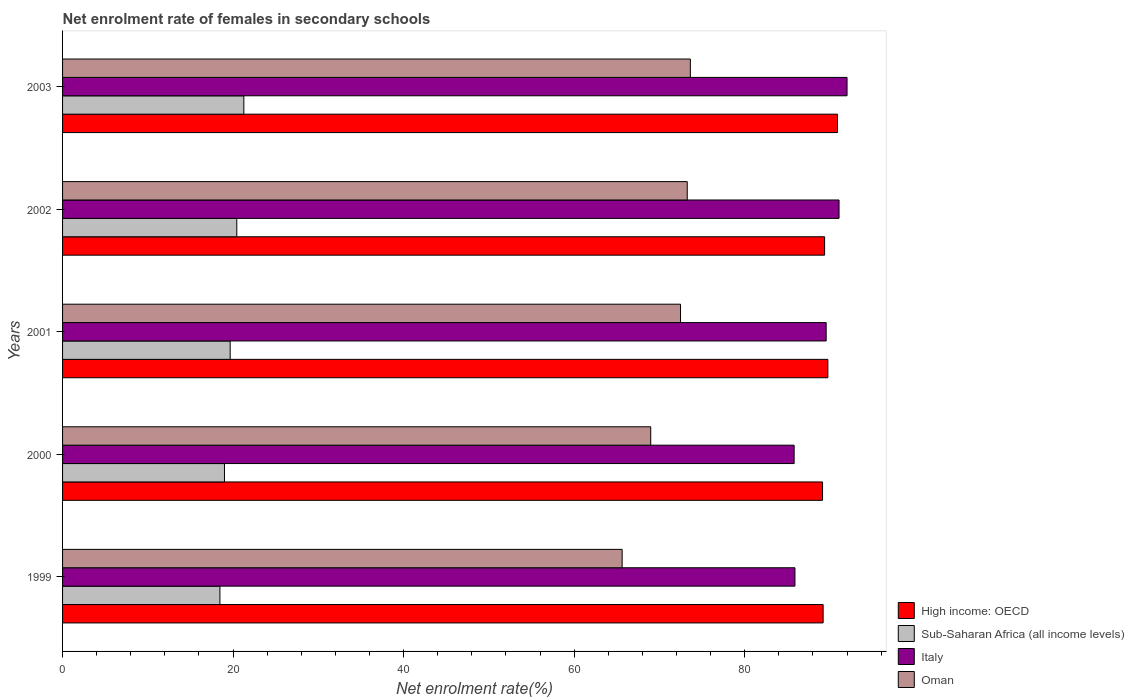How many groups of bars are there?
Your response must be concise. 5. How many bars are there on the 2nd tick from the top?
Provide a succinct answer. 4. In how many cases, is the number of bars for a given year not equal to the number of legend labels?
Provide a succinct answer. 0. What is the net enrolment rate of females in secondary schools in Italy in 2000?
Make the answer very short. 85.8. Across all years, what is the maximum net enrolment rate of females in secondary schools in Italy?
Your answer should be compact. 92.01. Across all years, what is the minimum net enrolment rate of females in secondary schools in Sub-Saharan Africa (all income levels)?
Make the answer very short. 18.45. In which year was the net enrolment rate of females in secondary schools in Oman maximum?
Offer a very short reply. 2003. In which year was the net enrolment rate of females in secondary schools in Sub-Saharan Africa (all income levels) minimum?
Provide a succinct answer. 1999. What is the total net enrolment rate of females in secondary schools in High income: OECD in the graph?
Provide a short and direct response. 448.35. What is the difference between the net enrolment rate of females in secondary schools in Sub-Saharan Africa (all income levels) in 2001 and that in 2002?
Your answer should be compact. -0.78. What is the difference between the net enrolment rate of females in secondary schools in Oman in 2001 and the net enrolment rate of females in secondary schools in Sub-Saharan Africa (all income levels) in 2003?
Your answer should be compact. 51.22. What is the average net enrolment rate of females in secondary schools in Sub-Saharan Africa (all income levels) per year?
Your response must be concise. 19.76. In the year 2003, what is the difference between the net enrolment rate of females in secondary schools in Oman and net enrolment rate of females in secondary schools in High income: OECD?
Keep it short and to the point. -17.26. In how many years, is the net enrolment rate of females in secondary schools in High income: OECD greater than 56 %?
Your answer should be compact. 5. What is the ratio of the net enrolment rate of females in secondary schools in High income: OECD in 2002 to that in 2003?
Keep it short and to the point. 0.98. Is the difference between the net enrolment rate of females in secondary schools in Oman in 2001 and 2003 greater than the difference between the net enrolment rate of females in secondary schools in High income: OECD in 2001 and 2003?
Make the answer very short. No. What is the difference between the highest and the second highest net enrolment rate of females in secondary schools in Sub-Saharan Africa (all income levels)?
Your response must be concise. 0.83. What is the difference between the highest and the lowest net enrolment rate of females in secondary schools in Sub-Saharan Africa (all income levels)?
Offer a terse response. 2.81. Is the sum of the net enrolment rate of females in secondary schools in Oman in 2000 and 2001 greater than the maximum net enrolment rate of females in secondary schools in High income: OECD across all years?
Your response must be concise. Yes. Is it the case that in every year, the sum of the net enrolment rate of females in secondary schools in Italy and net enrolment rate of females in secondary schools in High income: OECD is greater than the sum of net enrolment rate of females in secondary schools in Oman and net enrolment rate of females in secondary schools in Sub-Saharan Africa (all income levels)?
Provide a short and direct response. No. What does the 1st bar from the top in 2002 represents?
Provide a succinct answer. Oman. What does the 4th bar from the bottom in 1999 represents?
Make the answer very short. Oman. How many bars are there?
Keep it short and to the point. 20. How many years are there in the graph?
Make the answer very short. 5. Are the values on the major ticks of X-axis written in scientific E-notation?
Your answer should be very brief. No. Does the graph contain any zero values?
Give a very brief answer. No. Does the graph contain grids?
Ensure brevity in your answer.  No. What is the title of the graph?
Your answer should be very brief. Net enrolment rate of females in secondary schools. Does "Libya" appear as one of the legend labels in the graph?
Make the answer very short. No. What is the label or title of the X-axis?
Make the answer very short. Net enrolment rate(%). What is the label or title of the Y-axis?
Offer a terse response. Years. What is the Net enrolment rate(%) in High income: OECD in 1999?
Provide a succinct answer. 89.2. What is the Net enrolment rate(%) of Sub-Saharan Africa (all income levels) in 1999?
Keep it short and to the point. 18.45. What is the Net enrolment rate(%) in Italy in 1999?
Ensure brevity in your answer.  85.89. What is the Net enrolment rate(%) of Oman in 1999?
Offer a terse response. 65.63. What is the Net enrolment rate(%) in High income: OECD in 2000?
Provide a succinct answer. 89.13. What is the Net enrolment rate(%) of Sub-Saharan Africa (all income levels) in 2000?
Your response must be concise. 18.99. What is the Net enrolment rate(%) in Italy in 2000?
Your answer should be compact. 85.8. What is the Net enrolment rate(%) in Oman in 2000?
Your answer should be compact. 68.98. What is the Net enrolment rate(%) of High income: OECD in 2001?
Make the answer very short. 89.76. What is the Net enrolment rate(%) in Sub-Saharan Africa (all income levels) in 2001?
Your response must be concise. 19.66. What is the Net enrolment rate(%) in Italy in 2001?
Make the answer very short. 89.56. What is the Net enrolment rate(%) in Oman in 2001?
Keep it short and to the point. 72.48. What is the Net enrolment rate(%) in High income: OECD in 2002?
Offer a terse response. 89.37. What is the Net enrolment rate(%) of Sub-Saharan Africa (all income levels) in 2002?
Provide a succinct answer. 20.43. What is the Net enrolment rate(%) of Italy in 2002?
Provide a short and direct response. 91.07. What is the Net enrolment rate(%) in Oman in 2002?
Give a very brief answer. 73.26. What is the Net enrolment rate(%) of High income: OECD in 2003?
Keep it short and to the point. 90.89. What is the Net enrolment rate(%) in Sub-Saharan Africa (all income levels) in 2003?
Keep it short and to the point. 21.26. What is the Net enrolment rate(%) of Italy in 2003?
Keep it short and to the point. 92.01. What is the Net enrolment rate(%) in Oman in 2003?
Provide a short and direct response. 73.63. Across all years, what is the maximum Net enrolment rate(%) of High income: OECD?
Provide a short and direct response. 90.89. Across all years, what is the maximum Net enrolment rate(%) in Sub-Saharan Africa (all income levels)?
Provide a succinct answer. 21.26. Across all years, what is the maximum Net enrolment rate(%) of Italy?
Provide a short and direct response. 92.01. Across all years, what is the maximum Net enrolment rate(%) in Oman?
Provide a succinct answer. 73.63. Across all years, what is the minimum Net enrolment rate(%) of High income: OECD?
Your answer should be very brief. 89.13. Across all years, what is the minimum Net enrolment rate(%) in Sub-Saharan Africa (all income levels)?
Your answer should be compact. 18.45. Across all years, what is the minimum Net enrolment rate(%) in Italy?
Your answer should be very brief. 85.8. Across all years, what is the minimum Net enrolment rate(%) in Oman?
Provide a short and direct response. 65.63. What is the total Net enrolment rate(%) in High income: OECD in the graph?
Your answer should be compact. 448.35. What is the total Net enrolment rate(%) of Sub-Saharan Africa (all income levels) in the graph?
Make the answer very short. 98.79. What is the total Net enrolment rate(%) of Italy in the graph?
Your answer should be very brief. 444.32. What is the total Net enrolment rate(%) of Oman in the graph?
Keep it short and to the point. 353.97. What is the difference between the Net enrolment rate(%) in High income: OECD in 1999 and that in 2000?
Your answer should be compact. 0.07. What is the difference between the Net enrolment rate(%) of Sub-Saharan Africa (all income levels) in 1999 and that in 2000?
Give a very brief answer. -0.53. What is the difference between the Net enrolment rate(%) in Italy in 1999 and that in 2000?
Ensure brevity in your answer.  0.09. What is the difference between the Net enrolment rate(%) of Oman in 1999 and that in 2000?
Give a very brief answer. -3.35. What is the difference between the Net enrolment rate(%) of High income: OECD in 1999 and that in 2001?
Give a very brief answer. -0.56. What is the difference between the Net enrolment rate(%) in Sub-Saharan Africa (all income levels) in 1999 and that in 2001?
Offer a very short reply. -1.2. What is the difference between the Net enrolment rate(%) in Italy in 1999 and that in 2001?
Provide a succinct answer. -3.66. What is the difference between the Net enrolment rate(%) of Oman in 1999 and that in 2001?
Make the answer very short. -6.85. What is the difference between the Net enrolment rate(%) of High income: OECD in 1999 and that in 2002?
Your response must be concise. -0.17. What is the difference between the Net enrolment rate(%) of Sub-Saharan Africa (all income levels) in 1999 and that in 2002?
Your response must be concise. -1.98. What is the difference between the Net enrolment rate(%) in Italy in 1999 and that in 2002?
Your response must be concise. -5.17. What is the difference between the Net enrolment rate(%) of Oman in 1999 and that in 2002?
Your answer should be compact. -7.64. What is the difference between the Net enrolment rate(%) in High income: OECD in 1999 and that in 2003?
Provide a short and direct response. -1.68. What is the difference between the Net enrolment rate(%) of Sub-Saharan Africa (all income levels) in 1999 and that in 2003?
Provide a succinct answer. -2.81. What is the difference between the Net enrolment rate(%) of Italy in 1999 and that in 2003?
Ensure brevity in your answer.  -6.11. What is the difference between the Net enrolment rate(%) in Oman in 1999 and that in 2003?
Keep it short and to the point. -8. What is the difference between the Net enrolment rate(%) of High income: OECD in 2000 and that in 2001?
Ensure brevity in your answer.  -0.63. What is the difference between the Net enrolment rate(%) of Sub-Saharan Africa (all income levels) in 2000 and that in 2001?
Your answer should be very brief. -0.67. What is the difference between the Net enrolment rate(%) of Italy in 2000 and that in 2001?
Ensure brevity in your answer.  -3.76. What is the difference between the Net enrolment rate(%) of Oman in 2000 and that in 2001?
Ensure brevity in your answer.  -3.49. What is the difference between the Net enrolment rate(%) of High income: OECD in 2000 and that in 2002?
Make the answer very short. -0.24. What is the difference between the Net enrolment rate(%) of Sub-Saharan Africa (all income levels) in 2000 and that in 2002?
Make the answer very short. -1.45. What is the difference between the Net enrolment rate(%) in Italy in 2000 and that in 2002?
Your answer should be very brief. -5.27. What is the difference between the Net enrolment rate(%) of Oman in 2000 and that in 2002?
Offer a very short reply. -4.28. What is the difference between the Net enrolment rate(%) of High income: OECD in 2000 and that in 2003?
Make the answer very short. -1.75. What is the difference between the Net enrolment rate(%) of Sub-Saharan Africa (all income levels) in 2000 and that in 2003?
Your response must be concise. -2.27. What is the difference between the Net enrolment rate(%) of Italy in 2000 and that in 2003?
Keep it short and to the point. -6.21. What is the difference between the Net enrolment rate(%) of Oman in 2000 and that in 2003?
Ensure brevity in your answer.  -4.64. What is the difference between the Net enrolment rate(%) in High income: OECD in 2001 and that in 2002?
Ensure brevity in your answer.  0.38. What is the difference between the Net enrolment rate(%) of Sub-Saharan Africa (all income levels) in 2001 and that in 2002?
Ensure brevity in your answer.  -0.78. What is the difference between the Net enrolment rate(%) of Italy in 2001 and that in 2002?
Provide a short and direct response. -1.51. What is the difference between the Net enrolment rate(%) in Oman in 2001 and that in 2002?
Your answer should be very brief. -0.79. What is the difference between the Net enrolment rate(%) in High income: OECD in 2001 and that in 2003?
Provide a short and direct response. -1.13. What is the difference between the Net enrolment rate(%) in Sub-Saharan Africa (all income levels) in 2001 and that in 2003?
Your answer should be compact. -1.6. What is the difference between the Net enrolment rate(%) in Italy in 2001 and that in 2003?
Give a very brief answer. -2.45. What is the difference between the Net enrolment rate(%) of Oman in 2001 and that in 2003?
Provide a succinct answer. -1.15. What is the difference between the Net enrolment rate(%) in High income: OECD in 2002 and that in 2003?
Offer a very short reply. -1.51. What is the difference between the Net enrolment rate(%) in Sub-Saharan Africa (all income levels) in 2002 and that in 2003?
Keep it short and to the point. -0.83. What is the difference between the Net enrolment rate(%) in Italy in 2002 and that in 2003?
Provide a succinct answer. -0.94. What is the difference between the Net enrolment rate(%) of Oman in 2002 and that in 2003?
Your answer should be compact. -0.36. What is the difference between the Net enrolment rate(%) of High income: OECD in 1999 and the Net enrolment rate(%) of Sub-Saharan Africa (all income levels) in 2000?
Your answer should be compact. 70.21. What is the difference between the Net enrolment rate(%) in High income: OECD in 1999 and the Net enrolment rate(%) in Italy in 2000?
Make the answer very short. 3.4. What is the difference between the Net enrolment rate(%) of High income: OECD in 1999 and the Net enrolment rate(%) of Oman in 2000?
Make the answer very short. 20.22. What is the difference between the Net enrolment rate(%) of Sub-Saharan Africa (all income levels) in 1999 and the Net enrolment rate(%) of Italy in 2000?
Make the answer very short. -67.34. What is the difference between the Net enrolment rate(%) in Sub-Saharan Africa (all income levels) in 1999 and the Net enrolment rate(%) in Oman in 2000?
Make the answer very short. -50.53. What is the difference between the Net enrolment rate(%) of Italy in 1999 and the Net enrolment rate(%) of Oman in 2000?
Make the answer very short. 16.91. What is the difference between the Net enrolment rate(%) in High income: OECD in 1999 and the Net enrolment rate(%) in Sub-Saharan Africa (all income levels) in 2001?
Offer a terse response. 69.54. What is the difference between the Net enrolment rate(%) in High income: OECD in 1999 and the Net enrolment rate(%) in Italy in 2001?
Provide a short and direct response. -0.36. What is the difference between the Net enrolment rate(%) of High income: OECD in 1999 and the Net enrolment rate(%) of Oman in 2001?
Your answer should be very brief. 16.72. What is the difference between the Net enrolment rate(%) of Sub-Saharan Africa (all income levels) in 1999 and the Net enrolment rate(%) of Italy in 2001?
Ensure brevity in your answer.  -71.1. What is the difference between the Net enrolment rate(%) in Sub-Saharan Africa (all income levels) in 1999 and the Net enrolment rate(%) in Oman in 2001?
Your response must be concise. -54.02. What is the difference between the Net enrolment rate(%) of Italy in 1999 and the Net enrolment rate(%) of Oman in 2001?
Offer a very short reply. 13.42. What is the difference between the Net enrolment rate(%) in High income: OECD in 1999 and the Net enrolment rate(%) in Sub-Saharan Africa (all income levels) in 2002?
Keep it short and to the point. 68.77. What is the difference between the Net enrolment rate(%) in High income: OECD in 1999 and the Net enrolment rate(%) in Italy in 2002?
Provide a short and direct response. -1.87. What is the difference between the Net enrolment rate(%) in High income: OECD in 1999 and the Net enrolment rate(%) in Oman in 2002?
Your answer should be very brief. 15.94. What is the difference between the Net enrolment rate(%) in Sub-Saharan Africa (all income levels) in 1999 and the Net enrolment rate(%) in Italy in 2002?
Provide a succinct answer. -72.61. What is the difference between the Net enrolment rate(%) in Sub-Saharan Africa (all income levels) in 1999 and the Net enrolment rate(%) in Oman in 2002?
Your response must be concise. -54.81. What is the difference between the Net enrolment rate(%) in Italy in 1999 and the Net enrolment rate(%) in Oman in 2002?
Make the answer very short. 12.63. What is the difference between the Net enrolment rate(%) of High income: OECD in 1999 and the Net enrolment rate(%) of Sub-Saharan Africa (all income levels) in 2003?
Provide a short and direct response. 67.94. What is the difference between the Net enrolment rate(%) in High income: OECD in 1999 and the Net enrolment rate(%) in Italy in 2003?
Offer a terse response. -2.8. What is the difference between the Net enrolment rate(%) of High income: OECD in 1999 and the Net enrolment rate(%) of Oman in 2003?
Ensure brevity in your answer.  15.57. What is the difference between the Net enrolment rate(%) of Sub-Saharan Africa (all income levels) in 1999 and the Net enrolment rate(%) of Italy in 2003?
Ensure brevity in your answer.  -73.55. What is the difference between the Net enrolment rate(%) in Sub-Saharan Africa (all income levels) in 1999 and the Net enrolment rate(%) in Oman in 2003?
Your response must be concise. -55.17. What is the difference between the Net enrolment rate(%) in Italy in 1999 and the Net enrolment rate(%) in Oman in 2003?
Make the answer very short. 12.27. What is the difference between the Net enrolment rate(%) of High income: OECD in 2000 and the Net enrolment rate(%) of Sub-Saharan Africa (all income levels) in 2001?
Keep it short and to the point. 69.47. What is the difference between the Net enrolment rate(%) of High income: OECD in 2000 and the Net enrolment rate(%) of Italy in 2001?
Keep it short and to the point. -0.43. What is the difference between the Net enrolment rate(%) in High income: OECD in 2000 and the Net enrolment rate(%) in Oman in 2001?
Your response must be concise. 16.65. What is the difference between the Net enrolment rate(%) in Sub-Saharan Africa (all income levels) in 2000 and the Net enrolment rate(%) in Italy in 2001?
Offer a terse response. -70.57. What is the difference between the Net enrolment rate(%) of Sub-Saharan Africa (all income levels) in 2000 and the Net enrolment rate(%) of Oman in 2001?
Your response must be concise. -53.49. What is the difference between the Net enrolment rate(%) in Italy in 2000 and the Net enrolment rate(%) in Oman in 2001?
Make the answer very short. 13.32. What is the difference between the Net enrolment rate(%) in High income: OECD in 2000 and the Net enrolment rate(%) in Sub-Saharan Africa (all income levels) in 2002?
Your response must be concise. 68.7. What is the difference between the Net enrolment rate(%) of High income: OECD in 2000 and the Net enrolment rate(%) of Italy in 2002?
Your response must be concise. -1.94. What is the difference between the Net enrolment rate(%) in High income: OECD in 2000 and the Net enrolment rate(%) in Oman in 2002?
Your answer should be very brief. 15.87. What is the difference between the Net enrolment rate(%) of Sub-Saharan Africa (all income levels) in 2000 and the Net enrolment rate(%) of Italy in 2002?
Provide a short and direct response. -72.08. What is the difference between the Net enrolment rate(%) of Sub-Saharan Africa (all income levels) in 2000 and the Net enrolment rate(%) of Oman in 2002?
Give a very brief answer. -54.27. What is the difference between the Net enrolment rate(%) in Italy in 2000 and the Net enrolment rate(%) in Oman in 2002?
Offer a very short reply. 12.54. What is the difference between the Net enrolment rate(%) of High income: OECD in 2000 and the Net enrolment rate(%) of Sub-Saharan Africa (all income levels) in 2003?
Provide a succinct answer. 67.87. What is the difference between the Net enrolment rate(%) in High income: OECD in 2000 and the Net enrolment rate(%) in Italy in 2003?
Offer a terse response. -2.87. What is the difference between the Net enrolment rate(%) of High income: OECD in 2000 and the Net enrolment rate(%) of Oman in 2003?
Provide a succinct answer. 15.5. What is the difference between the Net enrolment rate(%) of Sub-Saharan Africa (all income levels) in 2000 and the Net enrolment rate(%) of Italy in 2003?
Provide a succinct answer. -73.02. What is the difference between the Net enrolment rate(%) of Sub-Saharan Africa (all income levels) in 2000 and the Net enrolment rate(%) of Oman in 2003?
Your response must be concise. -54.64. What is the difference between the Net enrolment rate(%) in Italy in 2000 and the Net enrolment rate(%) in Oman in 2003?
Your response must be concise. 12.17. What is the difference between the Net enrolment rate(%) in High income: OECD in 2001 and the Net enrolment rate(%) in Sub-Saharan Africa (all income levels) in 2002?
Offer a terse response. 69.32. What is the difference between the Net enrolment rate(%) of High income: OECD in 2001 and the Net enrolment rate(%) of Italy in 2002?
Ensure brevity in your answer.  -1.31. What is the difference between the Net enrolment rate(%) of High income: OECD in 2001 and the Net enrolment rate(%) of Oman in 2002?
Offer a terse response. 16.49. What is the difference between the Net enrolment rate(%) in Sub-Saharan Africa (all income levels) in 2001 and the Net enrolment rate(%) in Italy in 2002?
Your answer should be very brief. -71.41. What is the difference between the Net enrolment rate(%) in Sub-Saharan Africa (all income levels) in 2001 and the Net enrolment rate(%) in Oman in 2002?
Offer a very short reply. -53.6. What is the difference between the Net enrolment rate(%) in Italy in 2001 and the Net enrolment rate(%) in Oman in 2002?
Keep it short and to the point. 16.29. What is the difference between the Net enrolment rate(%) of High income: OECD in 2001 and the Net enrolment rate(%) of Sub-Saharan Africa (all income levels) in 2003?
Your answer should be compact. 68.5. What is the difference between the Net enrolment rate(%) in High income: OECD in 2001 and the Net enrolment rate(%) in Italy in 2003?
Keep it short and to the point. -2.25. What is the difference between the Net enrolment rate(%) of High income: OECD in 2001 and the Net enrolment rate(%) of Oman in 2003?
Your answer should be very brief. 16.13. What is the difference between the Net enrolment rate(%) in Sub-Saharan Africa (all income levels) in 2001 and the Net enrolment rate(%) in Italy in 2003?
Make the answer very short. -72.35. What is the difference between the Net enrolment rate(%) in Sub-Saharan Africa (all income levels) in 2001 and the Net enrolment rate(%) in Oman in 2003?
Your answer should be compact. -53.97. What is the difference between the Net enrolment rate(%) in Italy in 2001 and the Net enrolment rate(%) in Oman in 2003?
Make the answer very short. 15.93. What is the difference between the Net enrolment rate(%) in High income: OECD in 2002 and the Net enrolment rate(%) in Sub-Saharan Africa (all income levels) in 2003?
Keep it short and to the point. 68.11. What is the difference between the Net enrolment rate(%) of High income: OECD in 2002 and the Net enrolment rate(%) of Italy in 2003?
Offer a very short reply. -2.63. What is the difference between the Net enrolment rate(%) in High income: OECD in 2002 and the Net enrolment rate(%) in Oman in 2003?
Ensure brevity in your answer.  15.75. What is the difference between the Net enrolment rate(%) in Sub-Saharan Africa (all income levels) in 2002 and the Net enrolment rate(%) in Italy in 2003?
Your answer should be compact. -71.57. What is the difference between the Net enrolment rate(%) in Sub-Saharan Africa (all income levels) in 2002 and the Net enrolment rate(%) in Oman in 2003?
Offer a terse response. -53.19. What is the difference between the Net enrolment rate(%) in Italy in 2002 and the Net enrolment rate(%) in Oman in 2003?
Provide a short and direct response. 17.44. What is the average Net enrolment rate(%) in High income: OECD per year?
Keep it short and to the point. 89.67. What is the average Net enrolment rate(%) of Sub-Saharan Africa (all income levels) per year?
Offer a terse response. 19.76. What is the average Net enrolment rate(%) in Italy per year?
Offer a very short reply. 88.86. What is the average Net enrolment rate(%) of Oman per year?
Provide a short and direct response. 70.79. In the year 1999, what is the difference between the Net enrolment rate(%) of High income: OECD and Net enrolment rate(%) of Sub-Saharan Africa (all income levels)?
Keep it short and to the point. 70.75. In the year 1999, what is the difference between the Net enrolment rate(%) in High income: OECD and Net enrolment rate(%) in Italy?
Offer a terse response. 3.31. In the year 1999, what is the difference between the Net enrolment rate(%) of High income: OECD and Net enrolment rate(%) of Oman?
Provide a succinct answer. 23.57. In the year 1999, what is the difference between the Net enrolment rate(%) of Sub-Saharan Africa (all income levels) and Net enrolment rate(%) of Italy?
Offer a very short reply. -67.44. In the year 1999, what is the difference between the Net enrolment rate(%) of Sub-Saharan Africa (all income levels) and Net enrolment rate(%) of Oman?
Offer a terse response. -47.17. In the year 1999, what is the difference between the Net enrolment rate(%) in Italy and Net enrolment rate(%) in Oman?
Your response must be concise. 20.27. In the year 2000, what is the difference between the Net enrolment rate(%) of High income: OECD and Net enrolment rate(%) of Sub-Saharan Africa (all income levels)?
Make the answer very short. 70.14. In the year 2000, what is the difference between the Net enrolment rate(%) of High income: OECD and Net enrolment rate(%) of Italy?
Give a very brief answer. 3.33. In the year 2000, what is the difference between the Net enrolment rate(%) of High income: OECD and Net enrolment rate(%) of Oman?
Keep it short and to the point. 20.15. In the year 2000, what is the difference between the Net enrolment rate(%) of Sub-Saharan Africa (all income levels) and Net enrolment rate(%) of Italy?
Your answer should be compact. -66.81. In the year 2000, what is the difference between the Net enrolment rate(%) in Sub-Saharan Africa (all income levels) and Net enrolment rate(%) in Oman?
Provide a short and direct response. -49.99. In the year 2000, what is the difference between the Net enrolment rate(%) in Italy and Net enrolment rate(%) in Oman?
Your answer should be very brief. 16.82. In the year 2001, what is the difference between the Net enrolment rate(%) of High income: OECD and Net enrolment rate(%) of Sub-Saharan Africa (all income levels)?
Provide a short and direct response. 70.1. In the year 2001, what is the difference between the Net enrolment rate(%) in High income: OECD and Net enrolment rate(%) in Italy?
Offer a very short reply. 0.2. In the year 2001, what is the difference between the Net enrolment rate(%) in High income: OECD and Net enrolment rate(%) in Oman?
Offer a very short reply. 17.28. In the year 2001, what is the difference between the Net enrolment rate(%) of Sub-Saharan Africa (all income levels) and Net enrolment rate(%) of Italy?
Ensure brevity in your answer.  -69.9. In the year 2001, what is the difference between the Net enrolment rate(%) in Sub-Saharan Africa (all income levels) and Net enrolment rate(%) in Oman?
Your answer should be very brief. -52.82. In the year 2001, what is the difference between the Net enrolment rate(%) of Italy and Net enrolment rate(%) of Oman?
Your answer should be very brief. 17.08. In the year 2002, what is the difference between the Net enrolment rate(%) of High income: OECD and Net enrolment rate(%) of Sub-Saharan Africa (all income levels)?
Make the answer very short. 68.94. In the year 2002, what is the difference between the Net enrolment rate(%) in High income: OECD and Net enrolment rate(%) in Italy?
Keep it short and to the point. -1.7. In the year 2002, what is the difference between the Net enrolment rate(%) in High income: OECD and Net enrolment rate(%) in Oman?
Offer a very short reply. 16.11. In the year 2002, what is the difference between the Net enrolment rate(%) of Sub-Saharan Africa (all income levels) and Net enrolment rate(%) of Italy?
Keep it short and to the point. -70.63. In the year 2002, what is the difference between the Net enrolment rate(%) of Sub-Saharan Africa (all income levels) and Net enrolment rate(%) of Oman?
Give a very brief answer. -52.83. In the year 2002, what is the difference between the Net enrolment rate(%) in Italy and Net enrolment rate(%) in Oman?
Your answer should be compact. 17.8. In the year 2003, what is the difference between the Net enrolment rate(%) in High income: OECD and Net enrolment rate(%) in Sub-Saharan Africa (all income levels)?
Your response must be concise. 69.63. In the year 2003, what is the difference between the Net enrolment rate(%) in High income: OECD and Net enrolment rate(%) in Italy?
Offer a terse response. -1.12. In the year 2003, what is the difference between the Net enrolment rate(%) of High income: OECD and Net enrolment rate(%) of Oman?
Your answer should be compact. 17.26. In the year 2003, what is the difference between the Net enrolment rate(%) in Sub-Saharan Africa (all income levels) and Net enrolment rate(%) in Italy?
Ensure brevity in your answer.  -70.75. In the year 2003, what is the difference between the Net enrolment rate(%) in Sub-Saharan Africa (all income levels) and Net enrolment rate(%) in Oman?
Your answer should be very brief. -52.37. In the year 2003, what is the difference between the Net enrolment rate(%) in Italy and Net enrolment rate(%) in Oman?
Give a very brief answer. 18.38. What is the ratio of the Net enrolment rate(%) in High income: OECD in 1999 to that in 2000?
Ensure brevity in your answer.  1. What is the ratio of the Net enrolment rate(%) in Sub-Saharan Africa (all income levels) in 1999 to that in 2000?
Your answer should be compact. 0.97. What is the ratio of the Net enrolment rate(%) of Oman in 1999 to that in 2000?
Offer a terse response. 0.95. What is the ratio of the Net enrolment rate(%) in Sub-Saharan Africa (all income levels) in 1999 to that in 2001?
Offer a very short reply. 0.94. What is the ratio of the Net enrolment rate(%) in Italy in 1999 to that in 2001?
Your answer should be very brief. 0.96. What is the ratio of the Net enrolment rate(%) of Oman in 1999 to that in 2001?
Provide a succinct answer. 0.91. What is the ratio of the Net enrolment rate(%) in Sub-Saharan Africa (all income levels) in 1999 to that in 2002?
Ensure brevity in your answer.  0.9. What is the ratio of the Net enrolment rate(%) in Italy in 1999 to that in 2002?
Make the answer very short. 0.94. What is the ratio of the Net enrolment rate(%) of Oman in 1999 to that in 2002?
Your answer should be very brief. 0.9. What is the ratio of the Net enrolment rate(%) in High income: OECD in 1999 to that in 2003?
Provide a short and direct response. 0.98. What is the ratio of the Net enrolment rate(%) in Sub-Saharan Africa (all income levels) in 1999 to that in 2003?
Provide a succinct answer. 0.87. What is the ratio of the Net enrolment rate(%) of Italy in 1999 to that in 2003?
Your answer should be compact. 0.93. What is the ratio of the Net enrolment rate(%) in Oman in 1999 to that in 2003?
Keep it short and to the point. 0.89. What is the ratio of the Net enrolment rate(%) of High income: OECD in 2000 to that in 2001?
Keep it short and to the point. 0.99. What is the ratio of the Net enrolment rate(%) in Sub-Saharan Africa (all income levels) in 2000 to that in 2001?
Offer a very short reply. 0.97. What is the ratio of the Net enrolment rate(%) in Italy in 2000 to that in 2001?
Ensure brevity in your answer.  0.96. What is the ratio of the Net enrolment rate(%) in Oman in 2000 to that in 2001?
Provide a succinct answer. 0.95. What is the ratio of the Net enrolment rate(%) in High income: OECD in 2000 to that in 2002?
Provide a short and direct response. 1. What is the ratio of the Net enrolment rate(%) of Sub-Saharan Africa (all income levels) in 2000 to that in 2002?
Make the answer very short. 0.93. What is the ratio of the Net enrolment rate(%) in Italy in 2000 to that in 2002?
Your response must be concise. 0.94. What is the ratio of the Net enrolment rate(%) in Oman in 2000 to that in 2002?
Ensure brevity in your answer.  0.94. What is the ratio of the Net enrolment rate(%) in High income: OECD in 2000 to that in 2003?
Keep it short and to the point. 0.98. What is the ratio of the Net enrolment rate(%) in Sub-Saharan Africa (all income levels) in 2000 to that in 2003?
Provide a short and direct response. 0.89. What is the ratio of the Net enrolment rate(%) of Italy in 2000 to that in 2003?
Provide a succinct answer. 0.93. What is the ratio of the Net enrolment rate(%) in Oman in 2000 to that in 2003?
Ensure brevity in your answer.  0.94. What is the ratio of the Net enrolment rate(%) in High income: OECD in 2001 to that in 2002?
Provide a short and direct response. 1. What is the ratio of the Net enrolment rate(%) of Italy in 2001 to that in 2002?
Give a very brief answer. 0.98. What is the ratio of the Net enrolment rate(%) of Oman in 2001 to that in 2002?
Ensure brevity in your answer.  0.99. What is the ratio of the Net enrolment rate(%) in High income: OECD in 2001 to that in 2003?
Provide a short and direct response. 0.99. What is the ratio of the Net enrolment rate(%) of Sub-Saharan Africa (all income levels) in 2001 to that in 2003?
Offer a terse response. 0.92. What is the ratio of the Net enrolment rate(%) in Italy in 2001 to that in 2003?
Your response must be concise. 0.97. What is the ratio of the Net enrolment rate(%) in Oman in 2001 to that in 2003?
Make the answer very short. 0.98. What is the ratio of the Net enrolment rate(%) in High income: OECD in 2002 to that in 2003?
Provide a succinct answer. 0.98. What is the ratio of the Net enrolment rate(%) of Sub-Saharan Africa (all income levels) in 2002 to that in 2003?
Your answer should be compact. 0.96. What is the ratio of the Net enrolment rate(%) of Italy in 2002 to that in 2003?
Your response must be concise. 0.99. What is the difference between the highest and the second highest Net enrolment rate(%) in High income: OECD?
Keep it short and to the point. 1.13. What is the difference between the highest and the second highest Net enrolment rate(%) of Sub-Saharan Africa (all income levels)?
Keep it short and to the point. 0.83. What is the difference between the highest and the second highest Net enrolment rate(%) of Italy?
Your response must be concise. 0.94. What is the difference between the highest and the second highest Net enrolment rate(%) of Oman?
Your answer should be compact. 0.36. What is the difference between the highest and the lowest Net enrolment rate(%) in High income: OECD?
Make the answer very short. 1.75. What is the difference between the highest and the lowest Net enrolment rate(%) of Sub-Saharan Africa (all income levels)?
Offer a terse response. 2.81. What is the difference between the highest and the lowest Net enrolment rate(%) in Italy?
Give a very brief answer. 6.21. What is the difference between the highest and the lowest Net enrolment rate(%) of Oman?
Provide a succinct answer. 8. 